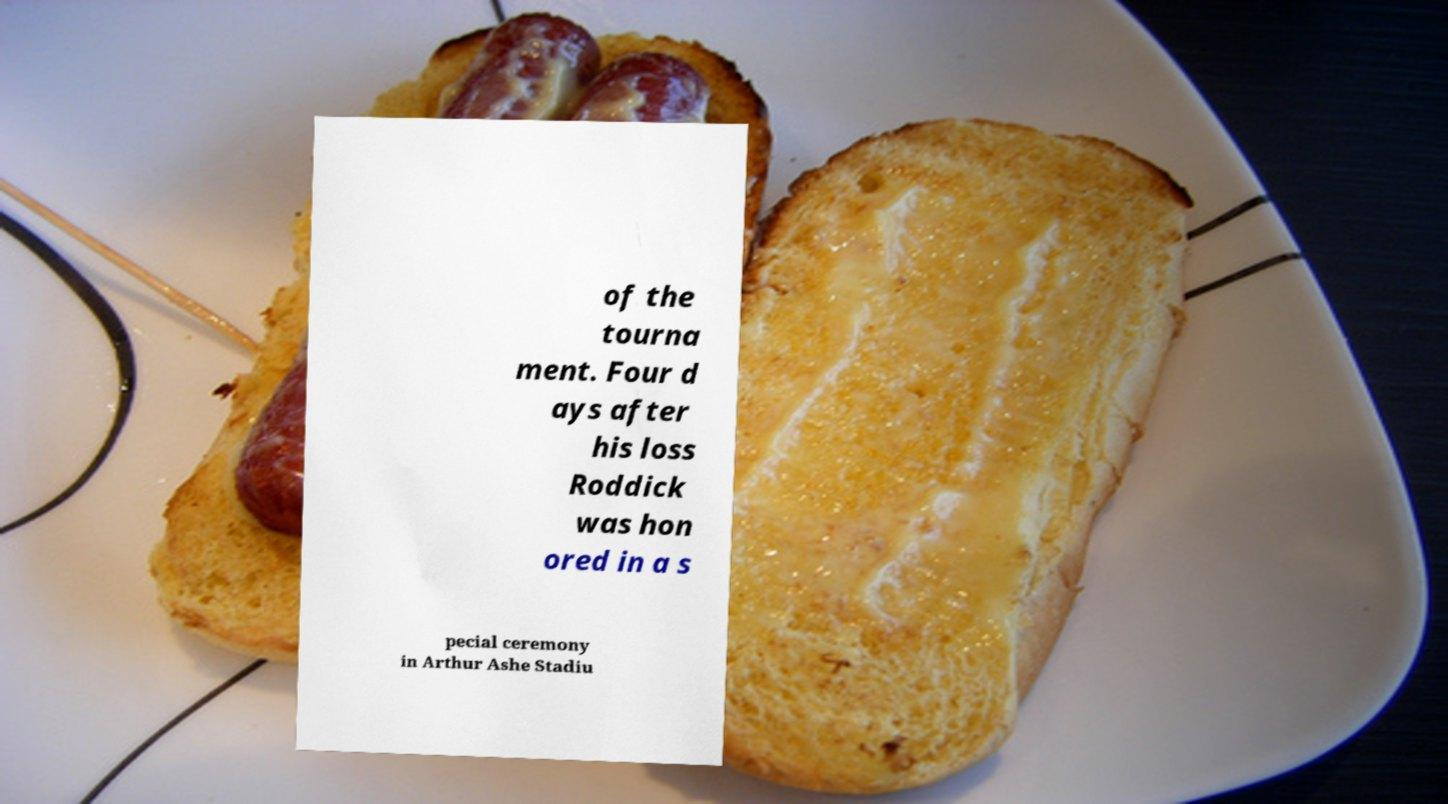I need the written content from this picture converted into text. Can you do that? of the tourna ment. Four d ays after his loss Roddick was hon ored in a s pecial ceremony in Arthur Ashe Stadiu 